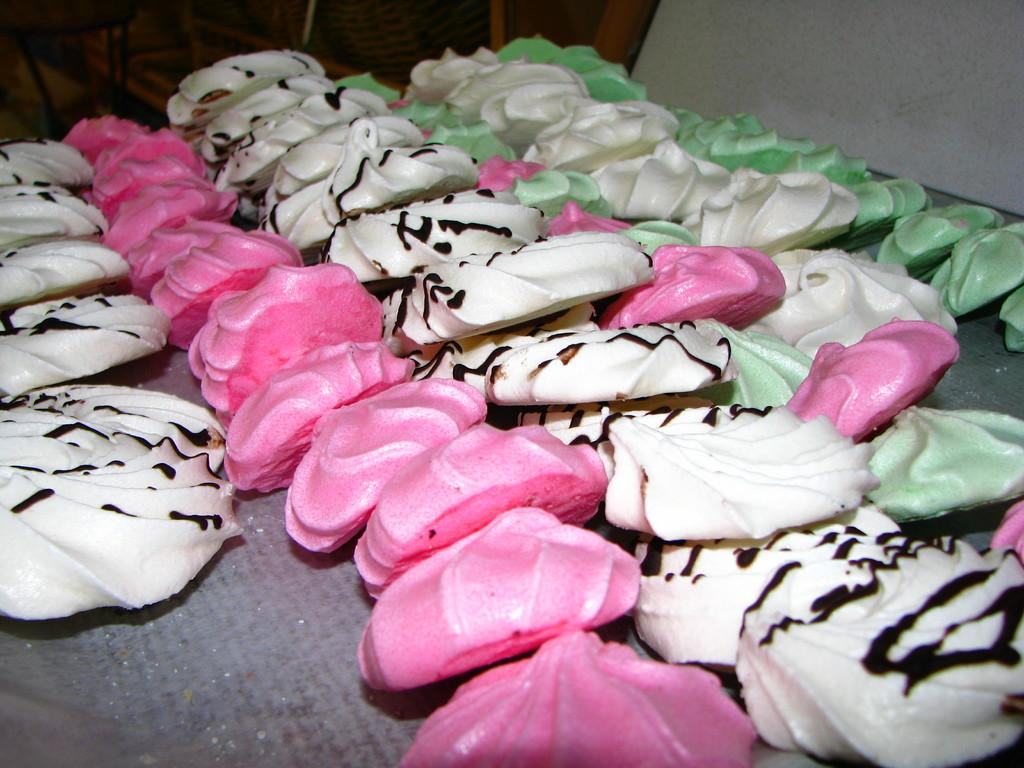What type of food is visible in the image? The image contains food with pink, white, and green colors. Can you describe the colors of the food in the image? The food has pink, white, and green colors. How many spiders are crawling on the food in the image? There are no spiders present in the image. What type of flight is taking off in the background of the image? There is no flight present in the image. 